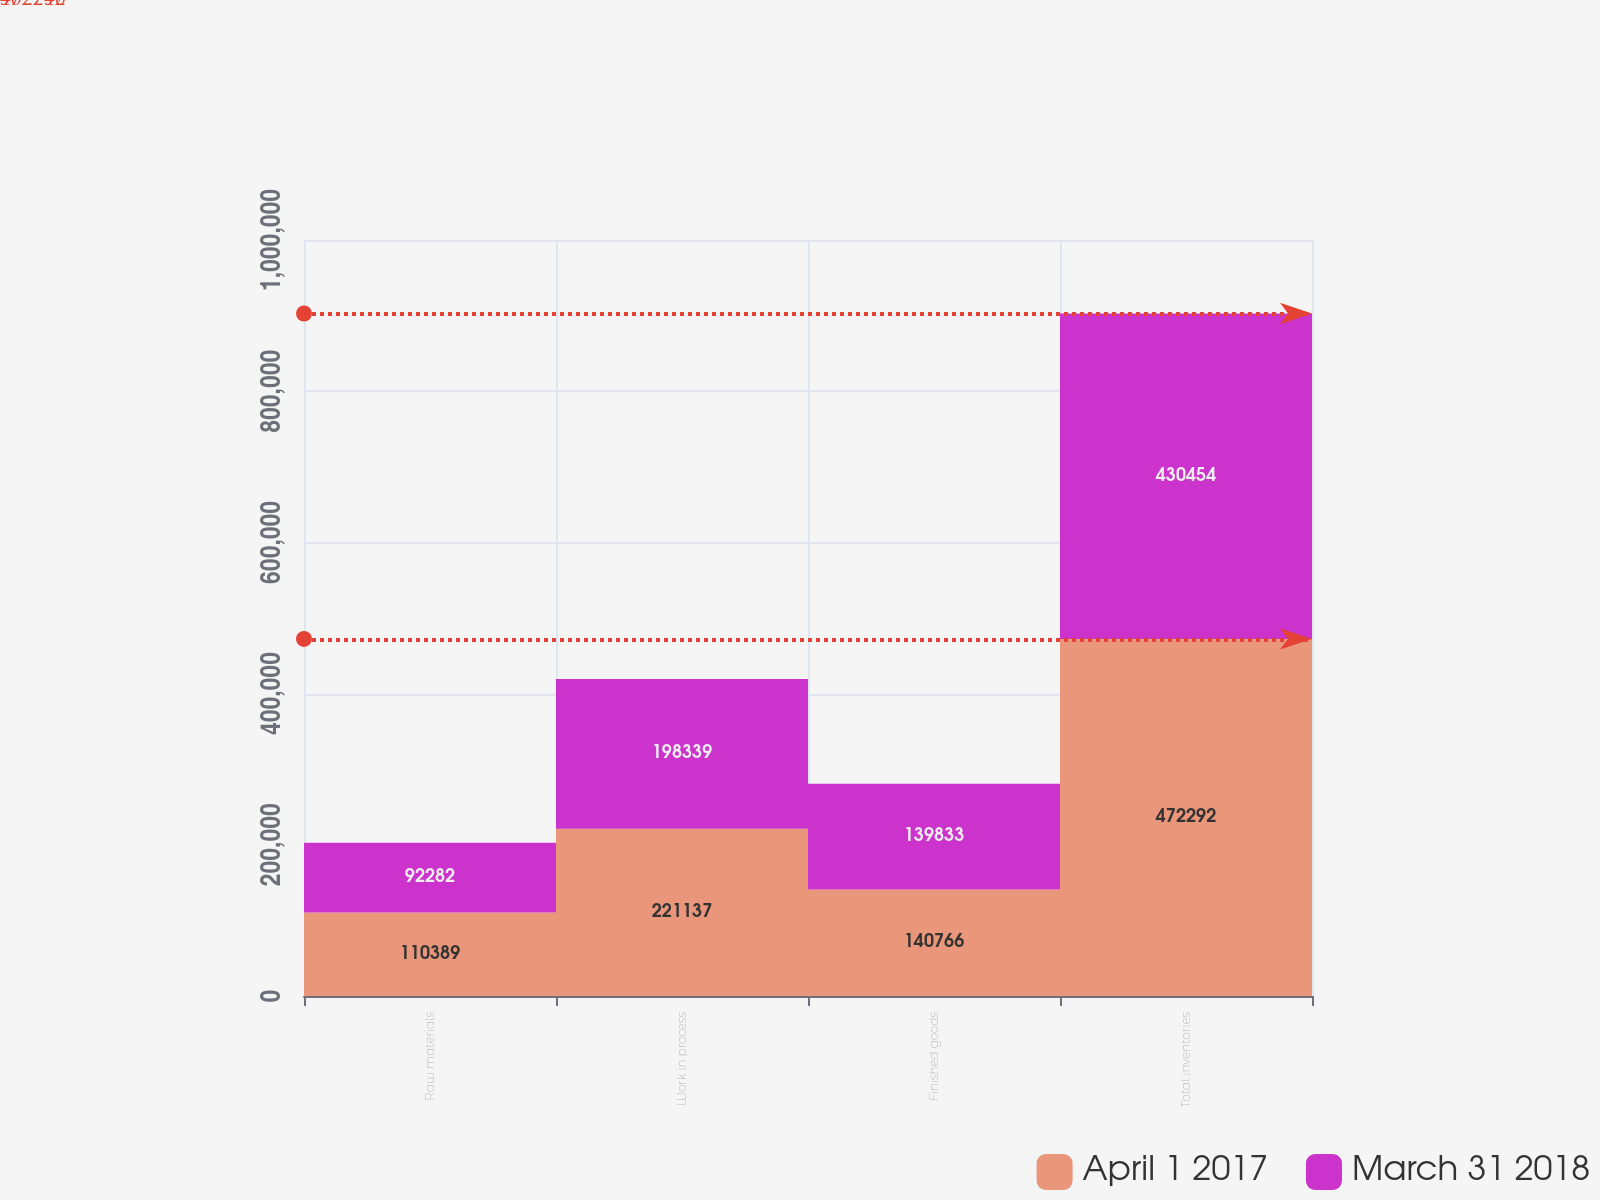Convert chart to OTSL. <chart><loc_0><loc_0><loc_500><loc_500><stacked_bar_chart><ecel><fcel>Raw materials<fcel>Work in process<fcel>Finished goods<fcel>Total inventories<nl><fcel>April 1 2017<fcel>110389<fcel>221137<fcel>140766<fcel>472292<nl><fcel>March 31 2018<fcel>92282<fcel>198339<fcel>139833<fcel>430454<nl></chart> 